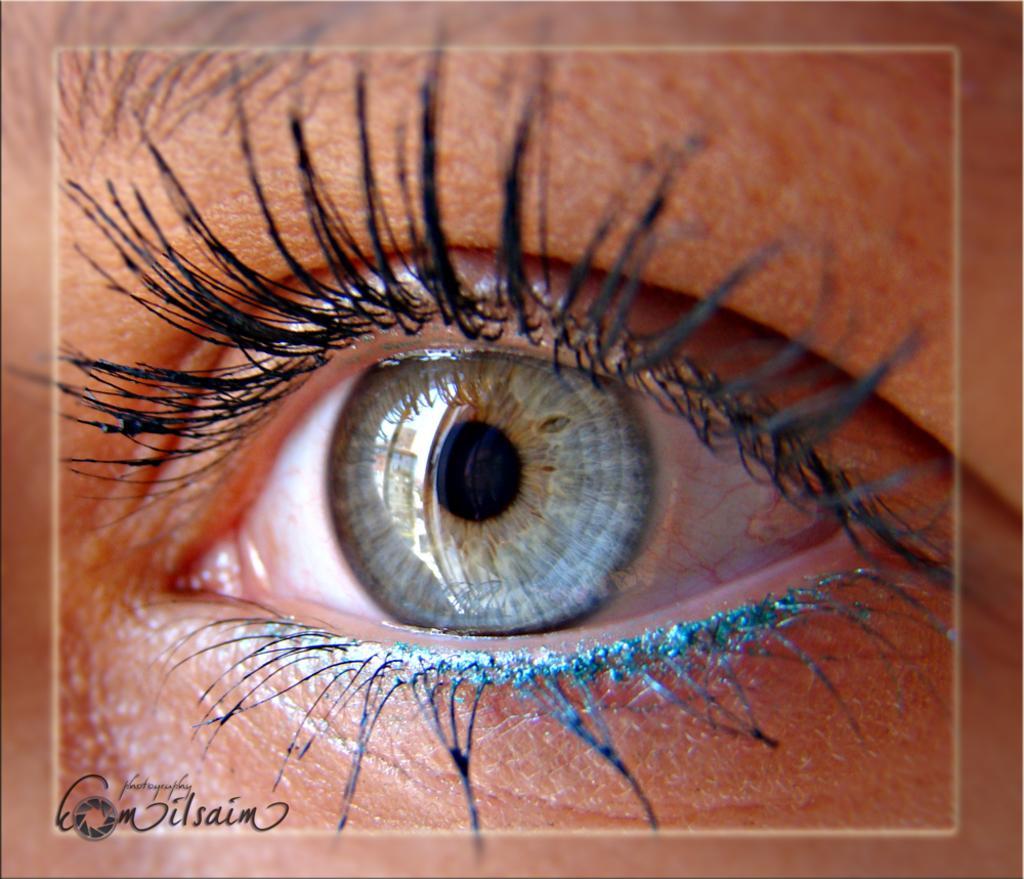In one or two sentences, can you explain what this image depicts? In this picture we can see a human eye with black eyelashes,black purple and blue green colored iris. 